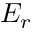Convert formula to latex. <formula><loc_0><loc_0><loc_500><loc_500>E _ { r }</formula> 